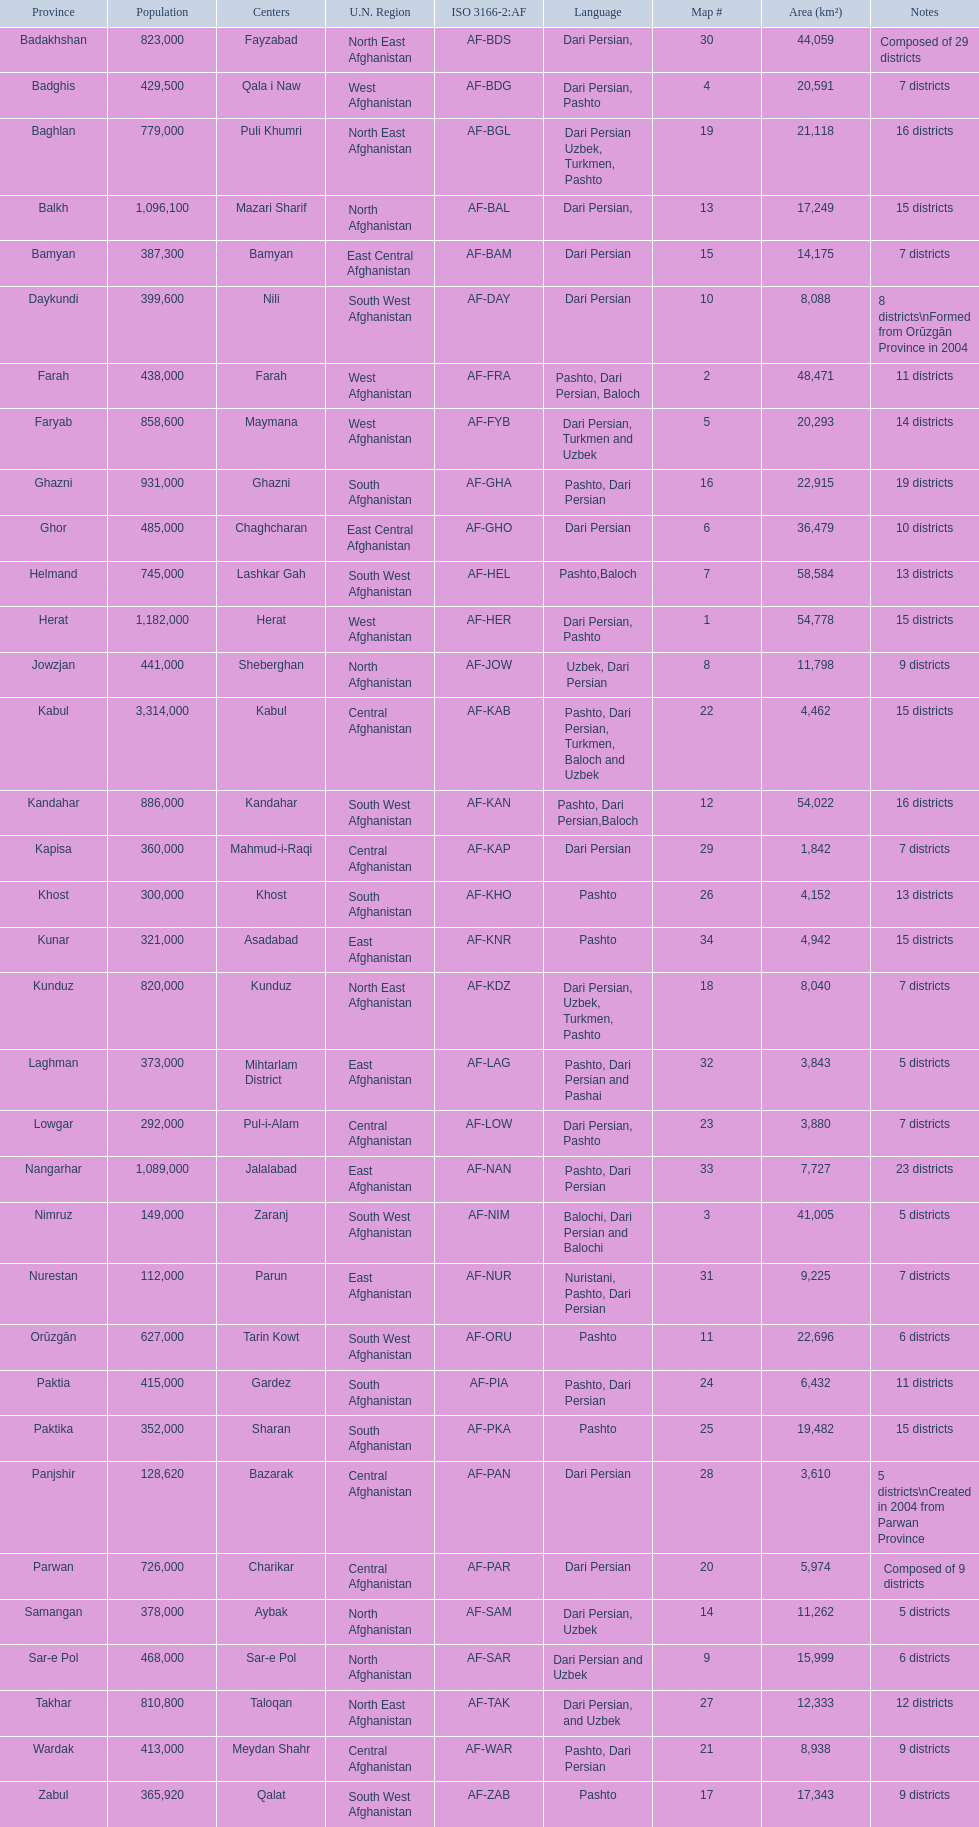Herat has a population of 1,182,000, can you list their languages Dari Persian, Pashto. 